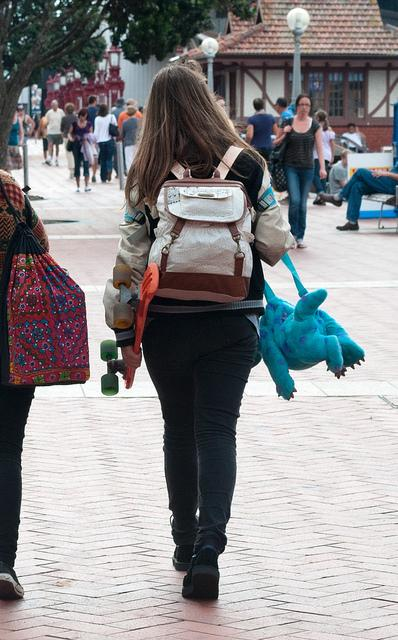What is the dominate color of the object the woman is carrying with her left arm? Please explain your reasoning. orange. The board she is carrying is not pink, red, or purple. 